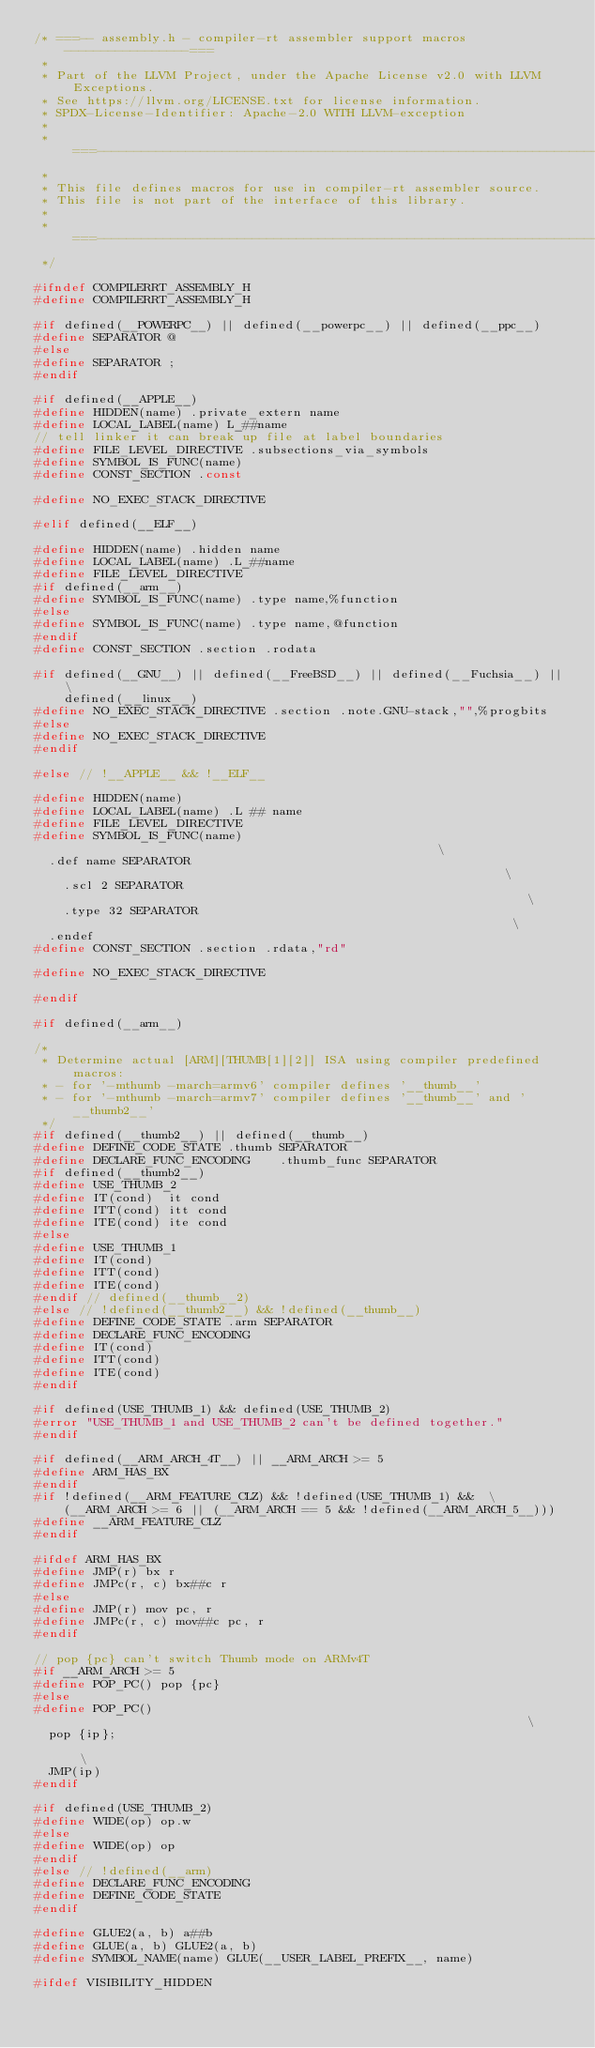<code> <loc_0><loc_0><loc_500><loc_500><_C_>/* ===-- assembly.h - compiler-rt assembler support macros -----------------===
 *
 * Part of the LLVM Project, under the Apache License v2.0 with LLVM Exceptions.
 * See https://llvm.org/LICENSE.txt for license information.
 * SPDX-License-Identifier: Apache-2.0 WITH LLVM-exception
 *
 * ===----------------------------------------------------------------------===
 *
 * This file defines macros for use in compiler-rt assembler source.
 * This file is not part of the interface of this library.
 *
 * ===----------------------------------------------------------------------===
 */

#ifndef COMPILERRT_ASSEMBLY_H
#define COMPILERRT_ASSEMBLY_H

#if defined(__POWERPC__) || defined(__powerpc__) || defined(__ppc__)
#define SEPARATOR @
#else
#define SEPARATOR ;
#endif

#if defined(__APPLE__)
#define HIDDEN(name) .private_extern name
#define LOCAL_LABEL(name) L_##name
// tell linker it can break up file at label boundaries
#define FILE_LEVEL_DIRECTIVE .subsections_via_symbols
#define SYMBOL_IS_FUNC(name)
#define CONST_SECTION .const

#define NO_EXEC_STACK_DIRECTIVE

#elif defined(__ELF__)

#define HIDDEN(name) .hidden name
#define LOCAL_LABEL(name) .L_##name
#define FILE_LEVEL_DIRECTIVE
#if defined(__arm__)
#define SYMBOL_IS_FUNC(name) .type name,%function
#else
#define SYMBOL_IS_FUNC(name) .type name,@function
#endif
#define CONST_SECTION .section .rodata

#if defined(__GNU__) || defined(__FreeBSD__) || defined(__Fuchsia__) || \
    defined(__linux__)
#define NO_EXEC_STACK_DIRECTIVE .section .note.GNU-stack,"",%progbits
#else
#define NO_EXEC_STACK_DIRECTIVE
#endif

#else // !__APPLE__ && !__ELF__

#define HIDDEN(name)
#define LOCAL_LABEL(name) .L ## name
#define FILE_LEVEL_DIRECTIVE
#define SYMBOL_IS_FUNC(name)                                                   \
  .def name SEPARATOR                                                          \
    .scl 2 SEPARATOR                                                           \
    .type 32 SEPARATOR                                                         \
  .endef
#define CONST_SECTION .section .rdata,"rd"

#define NO_EXEC_STACK_DIRECTIVE

#endif

#if defined(__arm__)

/*
 * Determine actual [ARM][THUMB[1][2]] ISA using compiler predefined macros:
 * - for '-mthumb -march=armv6' compiler defines '__thumb__'
 * - for '-mthumb -march=armv7' compiler defines '__thumb__' and '__thumb2__'
 */
#if defined(__thumb2__) || defined(__thumb__)
#define DEFINE_CODE_STATE .thumb SEPARATOR
#define DECLARE_FUNC_ENCODING    .thumb_func SEPARATOR
#if defined(__thumb2__)
#define USE_THUMB_2
#define IT(cond)  it cond
#define ITT(cond) itt cond
#define ITE(cond) ite cond
#else
#define USE_THUMB_1
#define IT(cond)
#define ITT(cond)
#define ITE(cond)
#endif // defined(__thumb__2)
#else // !defined(__thumb2__) && !defined(__thumb__)
#define DEFINE_CODE_STATE .arm SEPARATOR
#define DECLARE_FUNC_ENCODING
#define IT(cond)
#define ITT(cond)
#define ITE(cond)
#endif

#if defined(USE_THUMB_1) && defined(USE_THUMB_2)
#error "USE_THUMB_1 and USE_THUMB_2 can't be defined together."
#endif

#if defined(__ARM_ARCH_4T__) || __ARM_ARCH >= 5
#define ARM_HAS_BX
#endif
#if !defined(__ARM_FEATURE_CLZ) && !defined(USE_THUMB_1) &&  \
    (__ARM_ARCH >= 6 || (__ARM_ARCH == 5 && !defined(__ARM_ARCH_5__)))
#define __ARM_FEATURE_CLZ
#endif

#ifdef ARM_HAS_BX
#define JMP(r) bx r
#define JMPc(r, c) bx##c r
#else
#define JMP(r) mov pc, r
#define JMPc(r, c) mov##c pc, r
#endif

// pop {pc} can't switch Thumb mode on ARMv4T
#if __ARM_ARCH >= 5
#define POP_PC() pop {pc}
#else
#define POP_PC()                                                               \
  pop {ip};                                                                    \
  JMP(ip)
#endif

#if defined(USE_THUMB_2)
#define WIDE(op) op.w
#else
#define WIDE(op) op
#endif
#else // !defined(__arm)
#define DECLARE_FUNC_ENCODING
#define DEFINE_CODE_STATE
#endif

#define GLUE2(a, b) a##b
#define GLUE(a, b) GLUE2(a, b)
#define SYMBOL_NAME(name) GLUE(__USER_LABEL_PREFIX__, name)

#ifdef VISIBILITY_HIDDEN</code> 